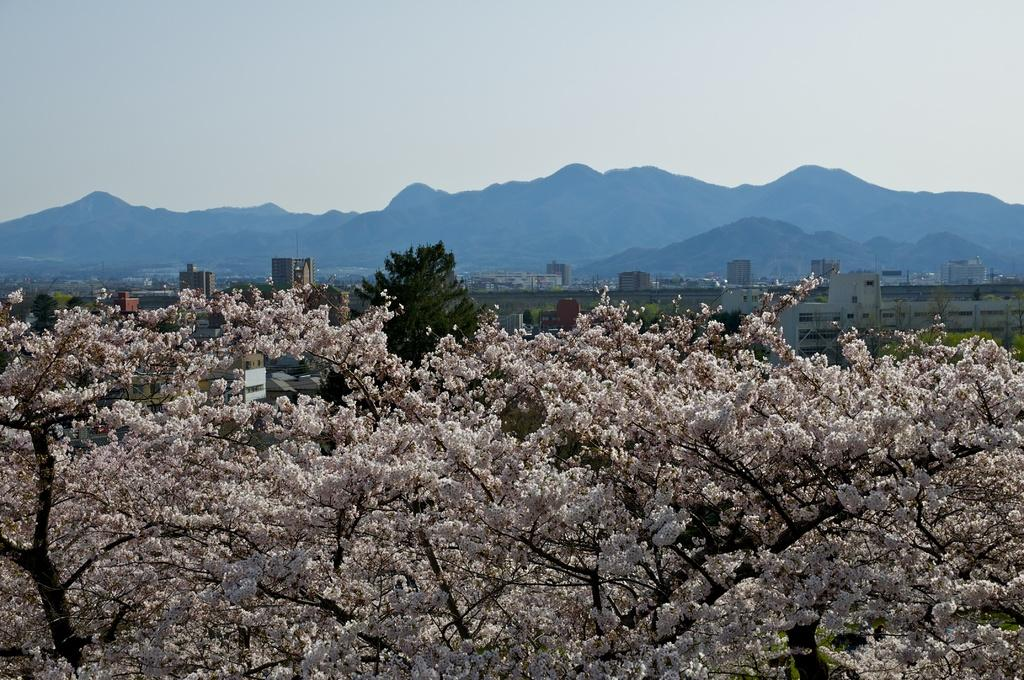What can be seen in the foreground of the picture? There are trees in the foreground of the picture. What is visible in the center of the picture? There are buildings and trees in the center of the picture. What type of landscape feature is present in the background of the picture? There are hills in the background of the picture. What is the condition of the sky in the image? The sky is cloudy. How many caves can be seen in the picture? There are no caves present in the image. What is the measurement of the knee in the picture? There is no reference to a knee in the image, so it is not possible to determine its measurement. 